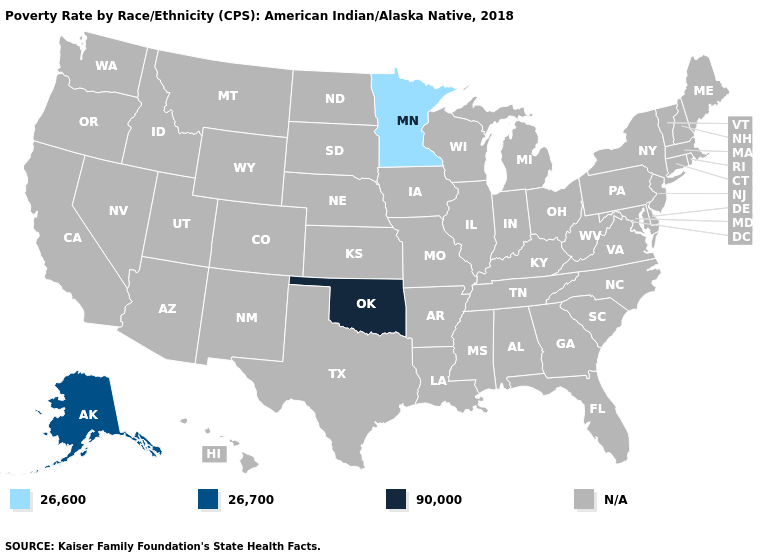What is the value of Vermont?
Answer briefly. N/A. Does Minnesota have the highest value in the USA?
Answer briefly. No. What is the value of Arkansas?
Keep it brief. N/A. What is the value of Kansas?
Short answer required. N/A. Name the states that have a value in the range N/A?
Give a very brief answer. Alabama, Arizona, Arkansas, California, Colorado, Connecticut, Delaware, Florida, Georgia, Hawaii, Idaho, Illinois, Indiana, Iowa, Kansas, Kentucky, Louisiana, Maine, Maryland, Massachusetts, Michigan, Mississippi, Missouri, Montana, Nebraska, Nevada, New Hampshire, New Jersey, New Mexico, New York, North Carolina, North Dakota, Ohio, Oregon, Pennsylvania, Rhode Island, South Carolina, South Dakota, Tennessee, Texas, Utah, Vermont, Virginia, Washington, West Virginia, Wisconsin, Wyoming. Is the legend a continuous bar?
Give a very brief answer. No. What is the value of Washington?
Short answer required. N/A. Name the states that have a value in the range 26,700?
Keep it brief. Alaska. What is the value of Louisiana?
Be succinct. N/A. Name the states that have a value in the range 26,600?
Quick response, please. Minnesota. Does the first symbol in the legend represent the smallest category?
Write a very short answer. Yes. 